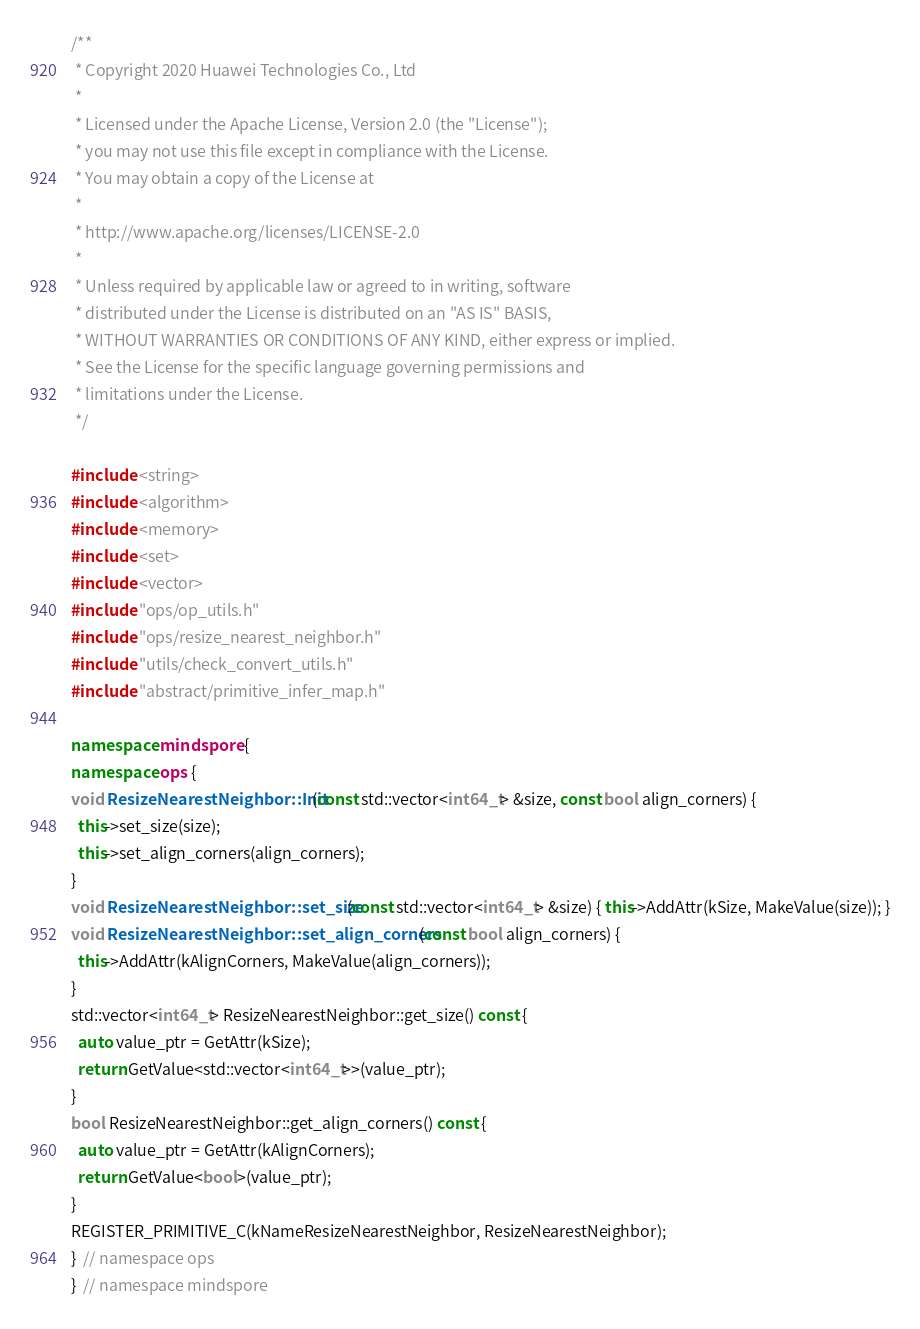Convert code to text. <code><loc_0><loc_0><loc_500><loc_500><_C++_>/**
 * Copyright 2020 Huawei Technologies Co., Ltd
 *
 * Licensed under the Apache License, Version 2.0 (the "License");
 * you may not use this file except in compliance with the License.
 * You may obtain a copy of the License at
 *
 * http://www.apache.org/licenses/LICENSE-2.0
 *
 * Unless required by applicable law or agreed to in writing, software
 * distributed under the License is distributed on an "AS IS" BASIS,
 * WITHOUT WARRANTIES OR CONDITIONS OF ANY KIND, either express or implied.
 * See the License for the specific language governing permissions and
 * limitations under the License.
 */

#include <string>
#include <algorithm>
#include <memory>
#include <set>
#include <vector>
#include "ops/op_utils.h"
#include "ops/resize_nearest_neighbor.h"
#include "utils/check_convert_utils.h"
#include "abstract/primitive_infer_map.h"

namespace mindspore {
namespace ops {
void ResizeNearestNeighbor::Init(const std::vector<int64_t> &size, const bool align_corners) {
  this->set_size(size);
  this->set_align_corners(align_corners);
}
void ResizeNearestNeighbor::set_size(const std::vector<int64_t> &size) { this->AddAttr(kSize, MakeValue(size)); }
void ResizeNearestNeighbor::set_align_corners(const bool align_corners) {
  this->AddAttr(kAlignCorners, MakeValue(align_corners));
}
std::vector<int64_t> ResizeNearestNeighbor::get_size() const {
  auto value_ptr = GetAttr(kSize);
  return GetValue<std::vector<int64_t>>(value_ptr);
}
bool ResizeNearestNeighbor::get_align_corners() const {
  auto value_ptr = GetAttr(kAlignCorners);
  return GetValue<bool>(value_ptr);
}
REGISTER_PRIMITIVE_C(kNameResizeNearestNeighbor, ResizeNearestNeighbor);
}  // namespace ops
}  // namespace mindspore
</code> 